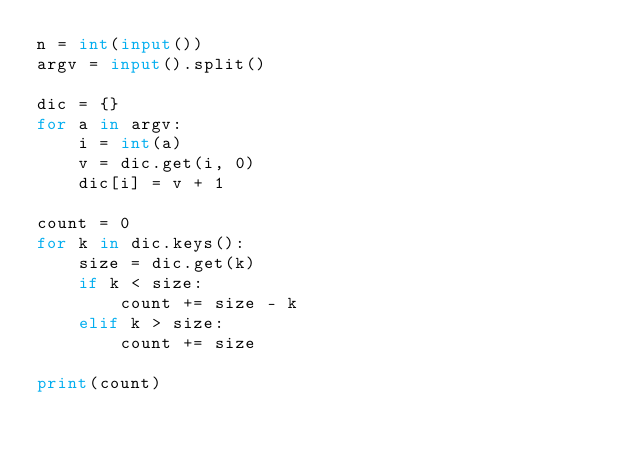<code> <loc_0><loc_0><loc_500><loc_500><_Python_>n = int(input())
argv = input().split()

dic = {}
for a in argv:
    i = int(a)
    v = dic.get(i, 0)
    dic[i] = v + 1

count = 0
for k in dic.keys():
    size = dic.get(k)
    if k < size:
        count += size - k
    elif k > size:
        count += size

print(count)
</code> 